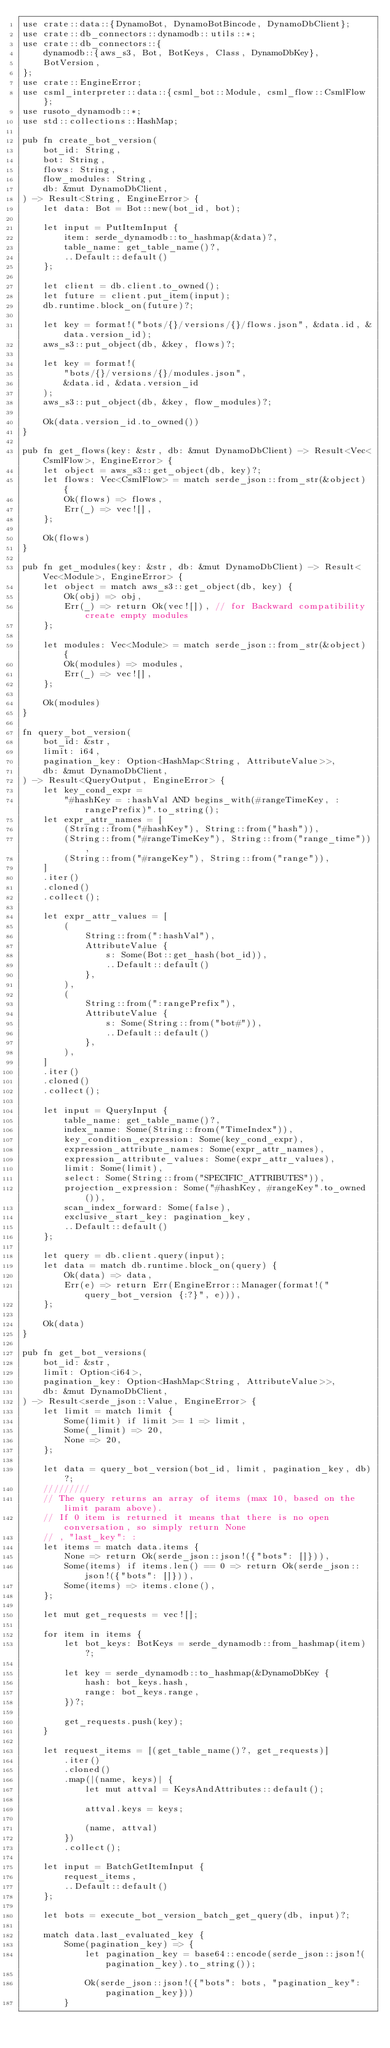Convert code to text. <code><loc_0><loc_0><loc_500><loc_500><_Rust_>use crate::data::{DynamoBot, DynamoBotBincode, DynamoDbClient};
use crate::db_connectors::dynamodb::utils::*;
use crate::db_connectors::{
    dynamodb::{aws_s3, Bot, BotKeys, Class, DynamoDbKey},
    BotVersion,
};
use crate::EngineError;
use csml_interpreter::data::{csml_bot::Module, csml_flow::CsmlFlow};
use rusoto_dynamodb::*;
use std::collections::HashMap;

pub fn create_bot_version(
    bot_id: String,
    bot: String,
    flows: String,
    flow_modules: String,
    db: &mut DynamoDbClient,
) -> Result<String, EngineError> {
    let data: Bot = Bot::new(bot_id, bot);

    let input = PutItemInput {
        item: serde_dynamodb::to_hashmap(&data)?,
        table_name: get_table_name()?,
        ..Default::default()
    };

    let client = db.client.to_owned();
    let future = client.put_item(input);
    db.runtime.block_on(future)?;

    let key = format!("bots/{}/versions/{}/flows.json", &data.id, &data.version_id);
    aws_s3::put_object(db, &key, flows)?;

    let key = format!(
        "bots/{}/versions/{}/modules.json",
        &data.id, &data.version_id
    );
    aws_s3::put_object(db, &key, flow_modules)?;

    Ok(data.version_id.to_owned())
}

pub fn get_flows(key: &str, db: &mut DynamoDbClient) -> Result<Vec<CsmlFlow>, EngineError> {
    let object = aws_s3::get_object(db, key)?;
    let flows: Vec<CsmlFlow> = match serde_json::from_str(&object) {
        Ok(flows) => flows,
        Err(_) => vec![],
    };

    Ok(flows)
}

pub fn get_modules(key: &str, db: &mut DynamoDbClient) -> Result<Vec<Module>, EngineError> {
    let object = match aws_s3::get_object(db, key) {
        Ok(obj) => obj,
        Err(_) => return Ok(vec![]), // for Backward compatibility create empty modules
    };

    let modules: Vec<Module> = match serde_json::from_str(&object) {
        Ok(modules) => modules,
        Err(_) => vec![],
    };

    Ok(modules)
}

fn query_bot_version(
    bot_id: &str,
    limit: i64,
    pagination_key: Option<HashMap<String, AttributeValue>>,
    db: &mut DynamoDbClient,
) -> Result<QueryOutput, EngineError> {
    let key_cond_expr =
        "#hashKey = :hashVal AND begins_with(#rangeTimeKey, :rangePrefix)".to_string();
    let expr_attr_names = [
        (String::from("#hashKey"), String::from("hash")),
        (String::from("#rangeTimeKey"), String::from("range_time")),
        (String::from("#rangeKey"), String::from("range")),
    ]
    .iter()
    .cloned()
    .collect();

    let expr_attr_values = [
        (
            String::from(":hashVal"),
            AttributeValue {
                s: Some(Bot::get_hash(bot_id)),
                ..Default::default()
            },
        ),
        (
            String::from(":rangePrefix"),
            AttributeValue {
                s: Some(String::from("bot#")),
                ..Default::default()
            },
        ),
    ]
    .iter()
    .cloned()
    .collect();

    let input = QueryInput {
        table_name: get_table_name()?,
        index_name: Some(String::from("TimeIndex")),
        key_condition_expression: Some(key_cond_expr),
        expression_attribute_names: Some(expr_attr_names),
        expression_attribute_values: Some(expr_attr_values),
        limit: Some(limit),
        select: Some(String::from("SPECIFIC_ATTRIBUTES")),
        projection_expression: Some("#hashKey, #rangeKey".to_owned()),
        scan_index_forward: Some(false),
        exclusive_start_key: pagination_key,
        ..Default::default()
    };

    let query = db.client.query(input);
    let data = match db.runtime.block_on(query) {
        Ok(data) => data,
        Err(e) => return Err(EngineError::Manager(format!("query_bot_version {:?}", e))),
    };

    Ok(data)
}

pub fn get_bot_versions(
    bot_id: &str,
    limit: Option<i64>,
    pagination_key: Option<HashMap<String, AttributeValue>>,
    db: &mut DynamoDbClient,
) -> Result<serde_json::Value, EngineError> {
    let limit = match limit {
        Some(limit) if limit >= 1 => limit,
        Some(_limit) => 20,
        None => 20,
    };

    let data = query_bot_version(bot_id, limit, pagination_key, db)?;
    /////////
    // The query returns an array of items (max 10, based on the limit param above).
    // If 0 item is returned it means that there is no open conversation, so simply return None
    // , "last_key": :
    let items = match data.items {
        None => return Ok(serde_json::json!({"bots": []})),
        Some(items) if items.len() == 0 => return Ok(serde_json::json!({"bots": []})),
        Some(items) => items.clone(),
    };

    let mut get_requests = vec![];

    for item in items {
        let bot_keys: BotKeys = serde_dynamodb::from_hashmap(item)?;

        let key = serde_dynamodb::to_hashmap(&DynamoDbKey {
            hash: bot_keys.hash,
            range: bot_keys.range,
        })?;

        get_requests.push(key);
    }

    let request_items = [(get_table_name()?, get_requests)]
        .iter()
        .cloned()
        .map(|(name, keys)| {
            let mut attval = KeysAndAttributes::default();

            attval.keys = keys;

            (name, attval)
        })
        .collect();

    let input = BatchGetItemInput {
        request_items,
        ..Default::default()
    };

    let bots = execute_bot_version_batch_get_query(db, input)?;

    match data.last_evaluated_key {
        Some(pagination_key) => {
            let pagination_key = base64::encode(serde_json::json!(pagination_key).to_string());

            Ok(serde_json::json!({"bots": bots, "pagination_key": pagination_key}))
        }</code> 